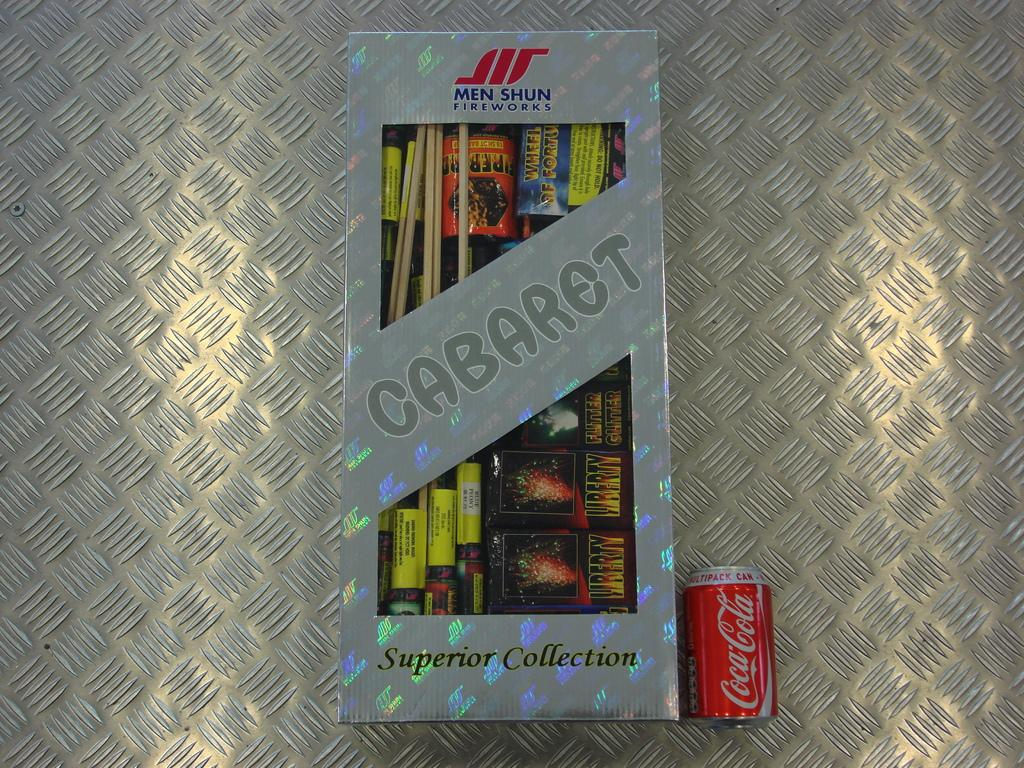<image>
Create a compact narrative representing the image presented. An assortment of fireworks called caberet superior collection 